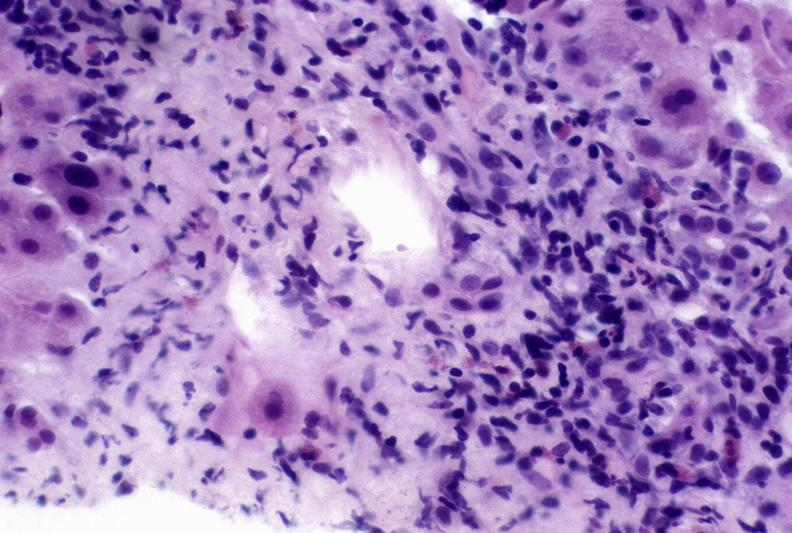what is present?
Answer the question using a single word or phrase. Liver 